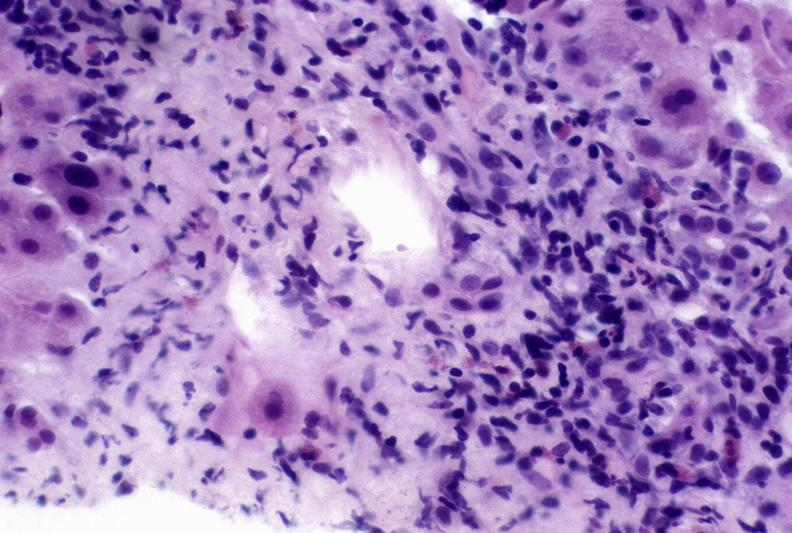what is present?
Answer the question using a single word or phrase. Liver 